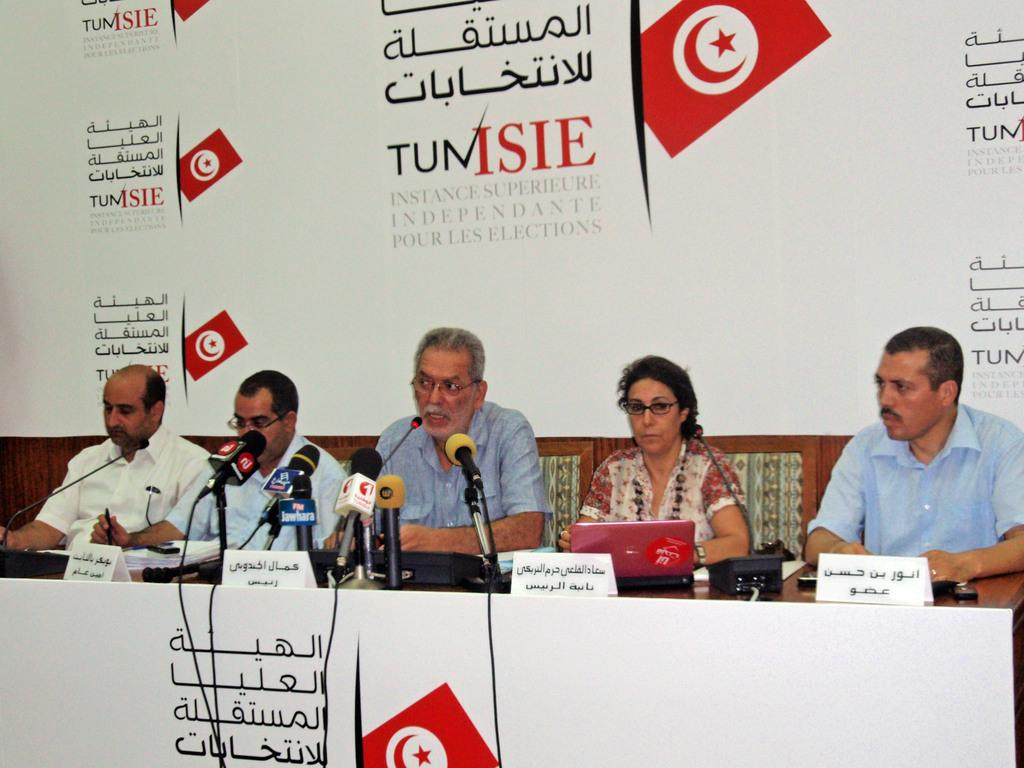How many people are in the image? There are five people in the image: four old men and one woman. What are the people doing in the image? The people are sitting in front of a table. What objects can be seen on the table? There are microphones, laptops, and a telephone on the table. What is visible on the wall behind the people? There is a wall with text behind the people. Can you see a bear in the image? No, there is no bear present in the image. What type of print is visible on the woman's shirt? There is no information about the woman's shirt in the provided facts, so we cannot determine if there is a print on it. 